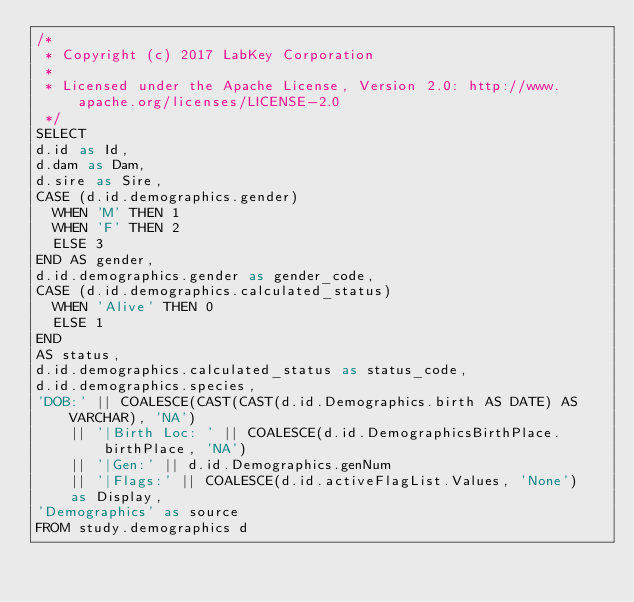<code> <loc_0><loc_0><loc_500><loc_500><_SQL_>/*
 * Copyright (c) 2017 LabKey Corporation
 *
 * Licensed under the Apache License, Version 2.0: http://www.apache.org/licenses/LICENSE-2.0
 */
SELECT
d.id as Id,
d.dam as Dam,
d.sire as Sire,
CASE (d.id.demographics.gender)
  WHEN 'M' THEN 1
  WHEN 'F' THEN 2
  ELSE 3
END AS gender,
d.id.demographics.gender as gender_code,
CASE (d.id.demographics.calculated_status)
  WHEN 'Alive' THEN 0
  ELSE 1
END
AS status,
d.id.demographics.calculated_status as status_code,
d.id.demographics.species,
'DOB:' || COALESCE(CAST(CAST(d.id.Demographics.birth AS DATE) AS VARCHAR), 'NA')
    || '|Birth Loc: ' || COALESCE(d.id.DemographicsBirthPlace.birthPlace, 'NA')
    || '|Gen:' || d.id.Demographics.genNum
    || '|Flags:' || COALESCE(d.id.activeFlagList.Values, 'None')
    as Display,
'Demographics' as source
FROM study.demographics d</code> 